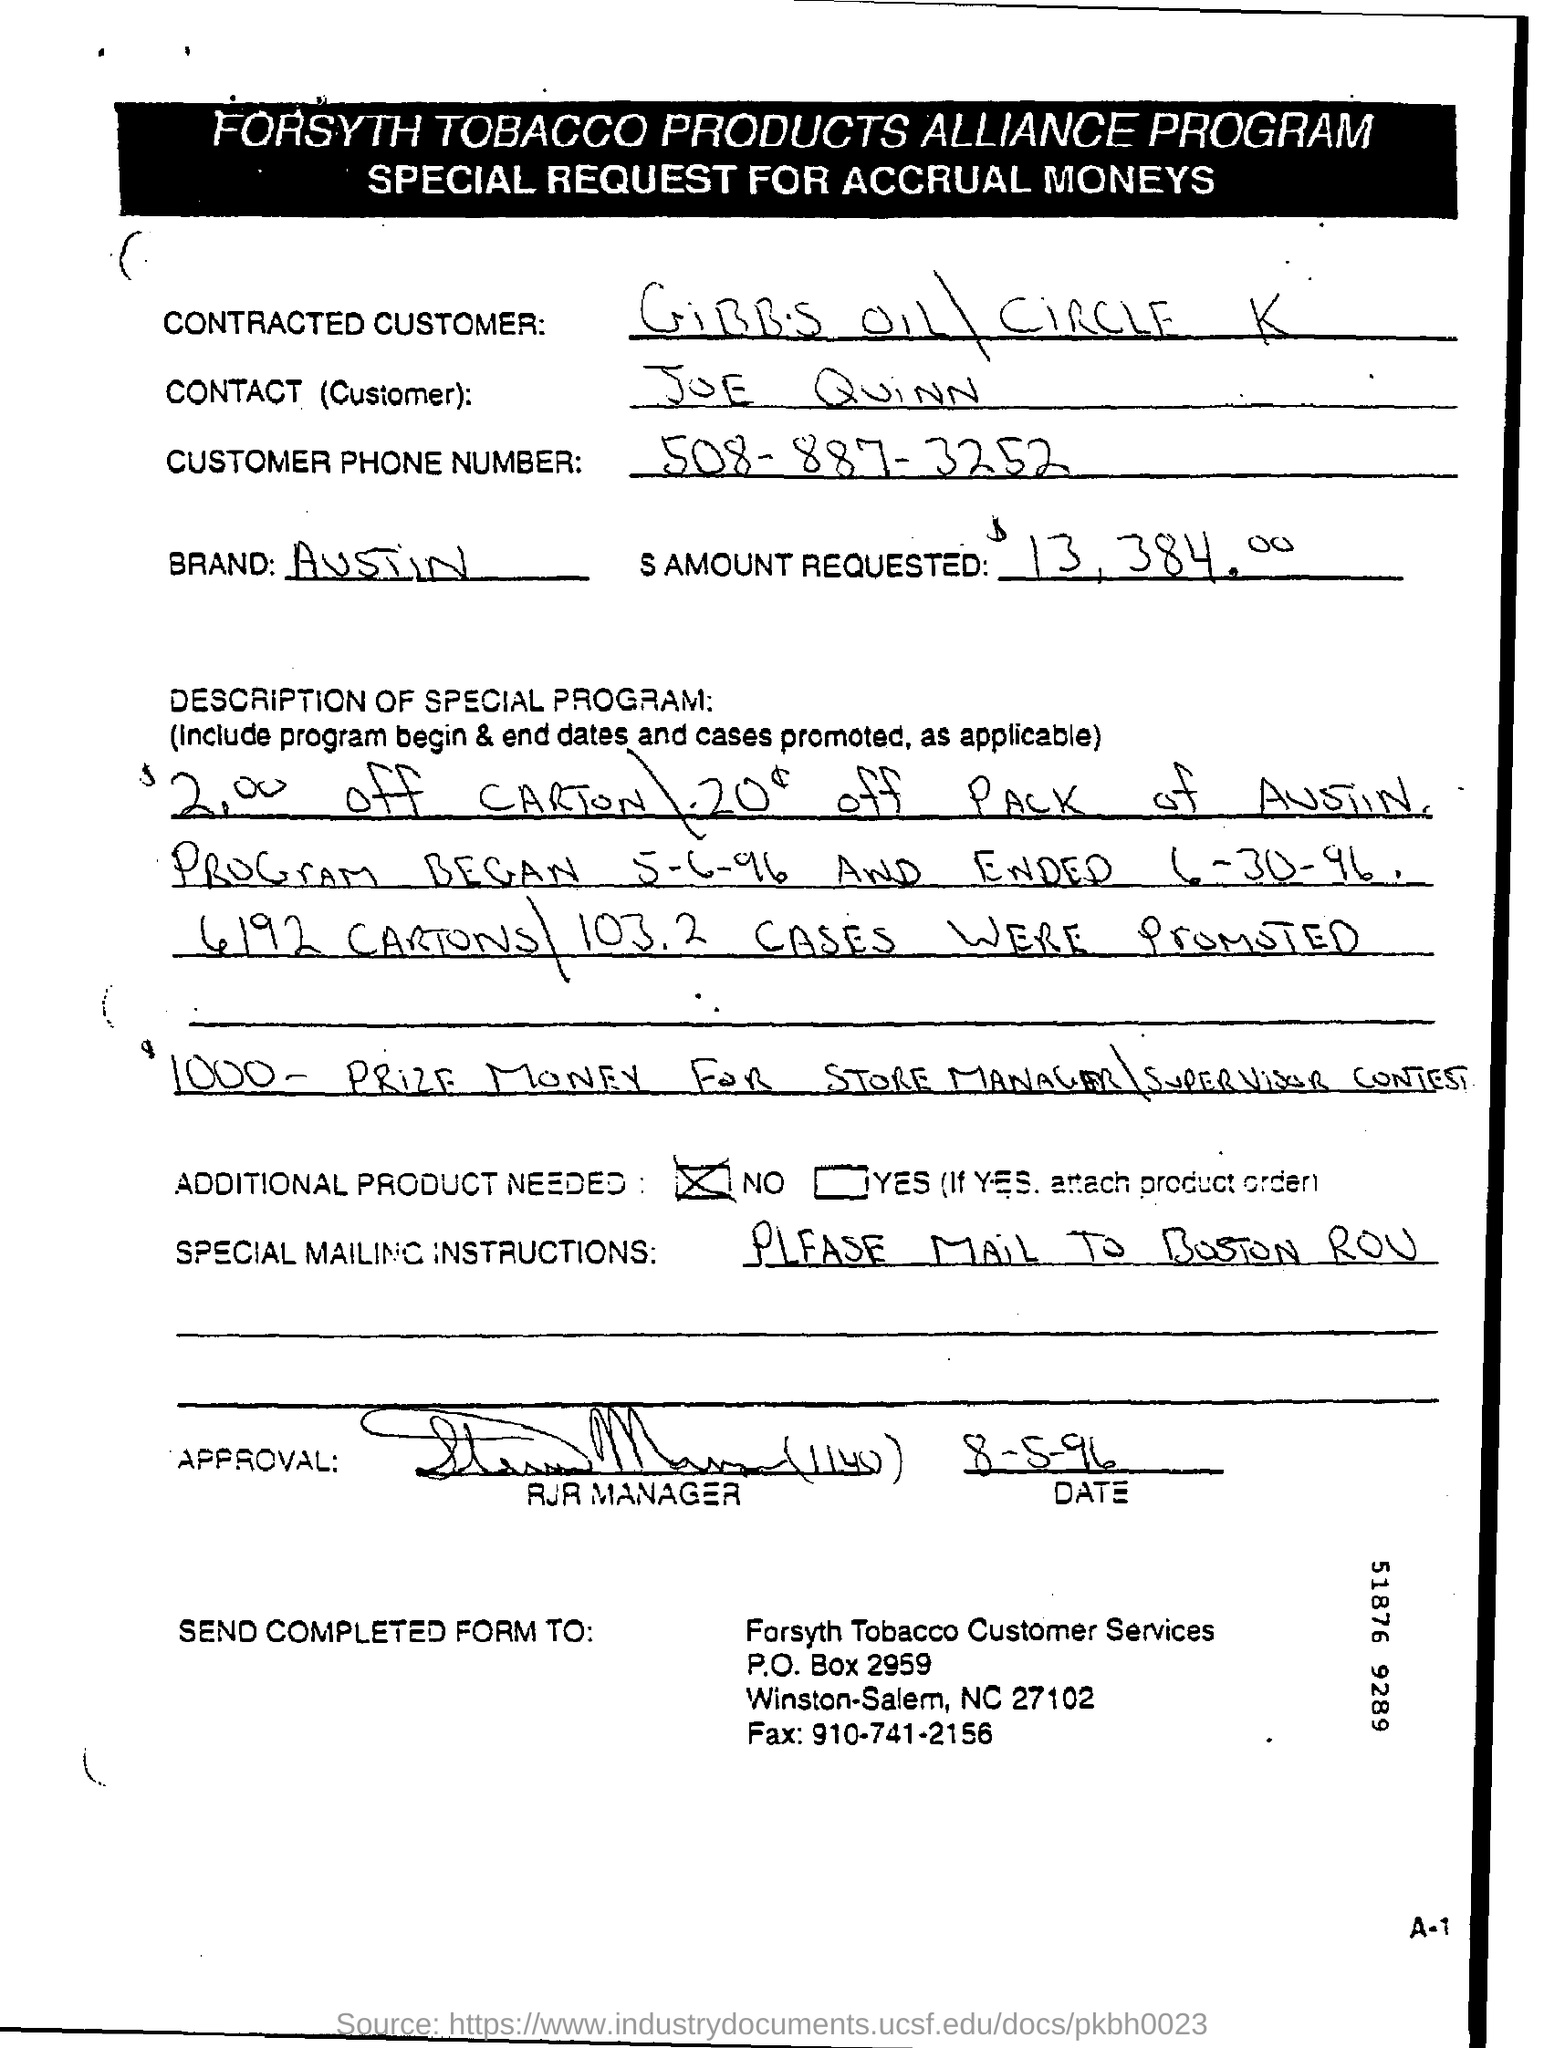What is the name of the brand?
Keep it short and to the point. AUSTIN. Write the phone number of the customer?
Your answer should be very brief. 508-887-3252. How much amount is requested for accrual moneys?
Your answer should be compact. $13,384.00. What is the special mailing instructions given?
Your answer should be very brief. PLEASE MAIL TO BOSTON ROU. 